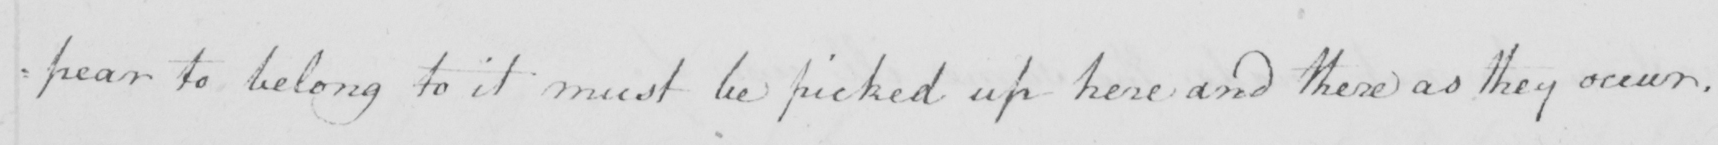Please provide the text content of this handwritten line. pear to belong to it must be picked up here and there as they occur . 